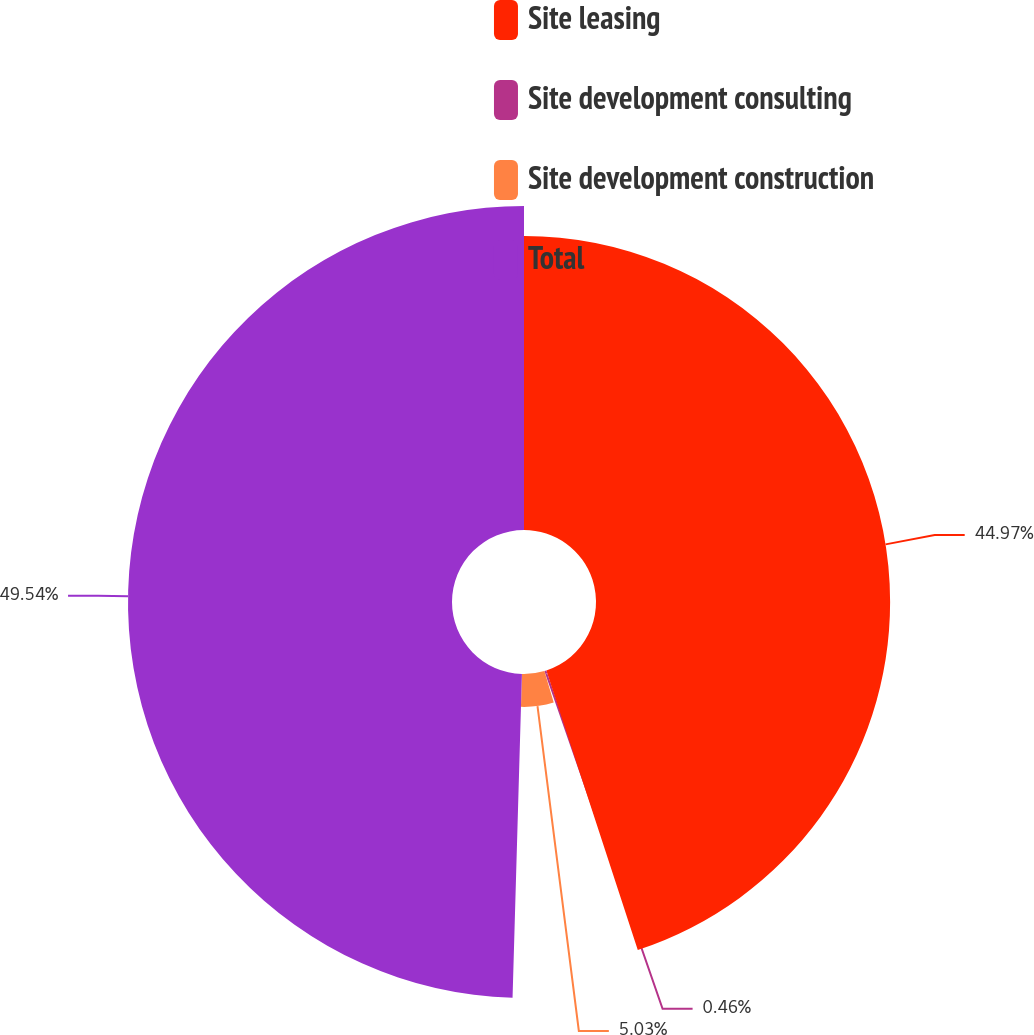<chart> <loc_0><loc_0><loc_500><loc_500><pie_chart><fcel>Site leasing<fcel>Site development consulting<fcel>Site development construction<fcel>Total<nl><fcel>44.97%<fcel>0.46%<fcel>5.03%<fcel>49.54%<nl></chart> 